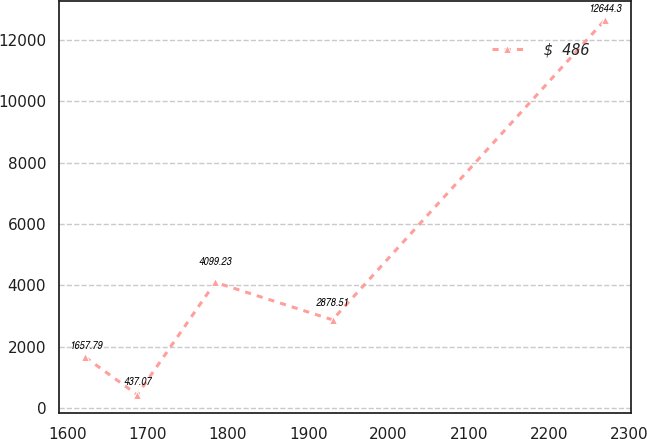<chart> <loc_0><loc_0><loc_500><loc_500><line_chart><ecel><fcel>$ 486<nl><fcel>1622.36<fcel>1657.79<nl><fcel>1687.1<fcel>437.07<nl><fcel>1784.31<fcel>4099.23<nl><fcel>1930.37<fcel>2878.51<nl><fcel>2269.74<fcel>12644.3<nl></chart> 